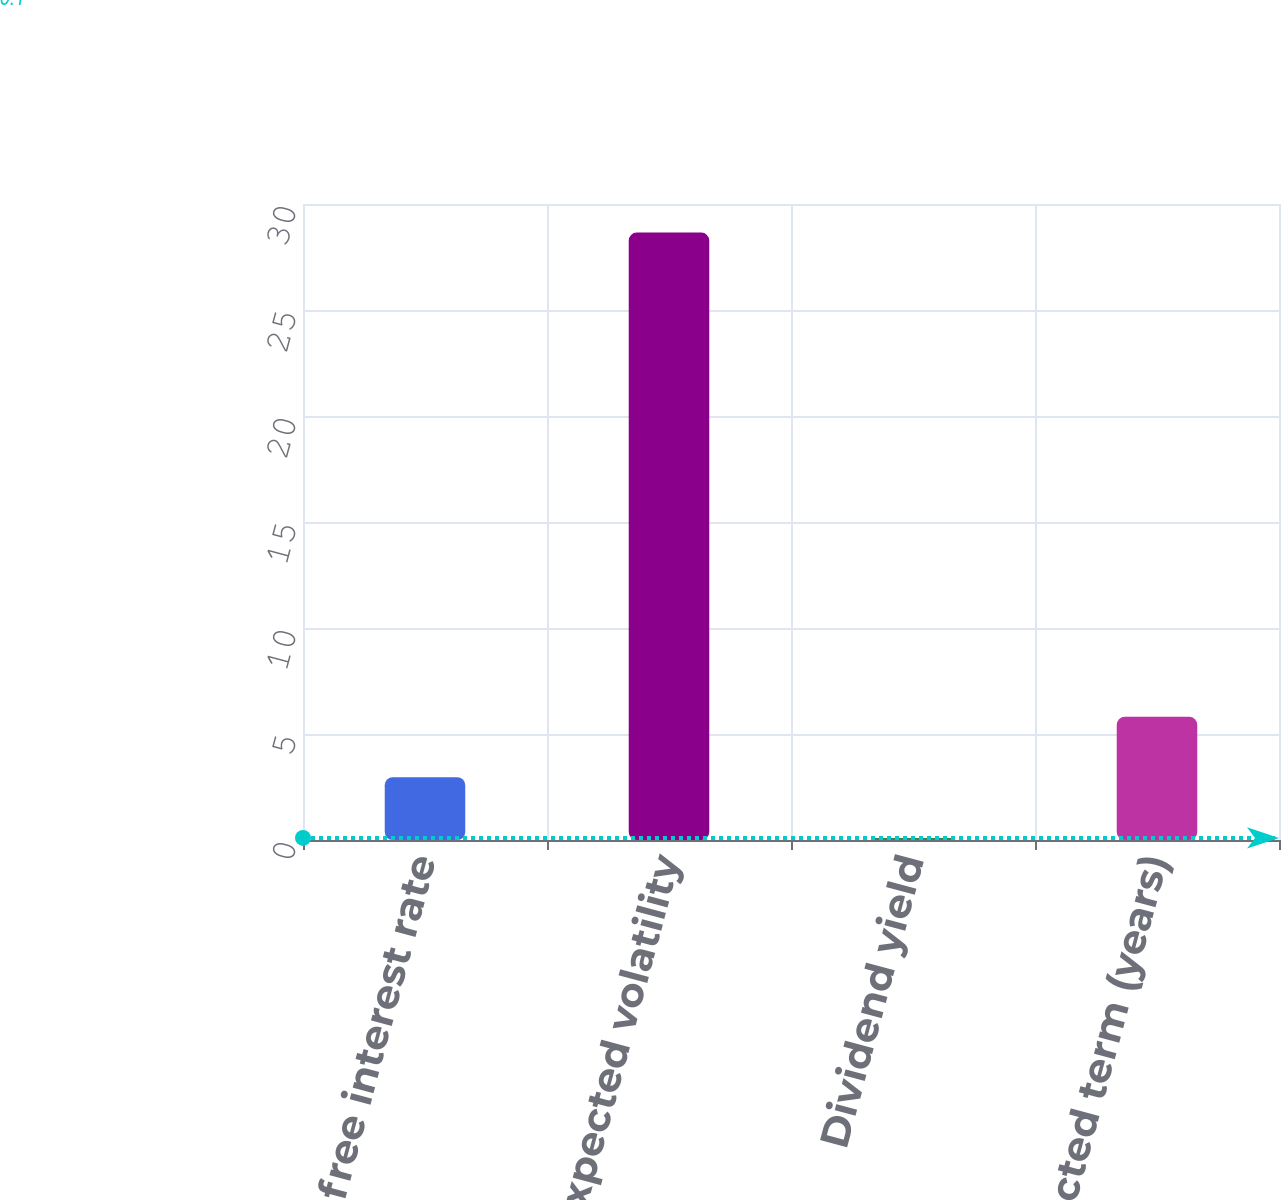Convert chart. <chart><loc_0><loc_0><loc_500><loc_500><bar_chart><fcel>Risk-free interest rate<fcel>Expected volatility<fcel>Dividend yield<fcel>Expected term (years)<nl><fcel>2.96<fcel>28.65<fcel>0.1<fcel>5.81<nl></chart> 